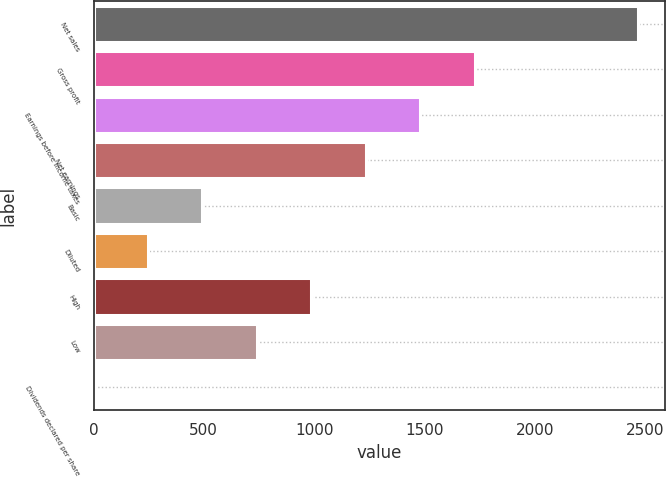Convert chart. <chart><loc_0><loc_0><loc_500><loc_500><bar_chart><fcel>Net sales<fcel>Gross profit<fcel>Earnings before income taxes<fcel>Net earnings<fcel>Basic<fcel>Diluted<fcel>High<fcel>Low<fcel>Dividends declared per share<nl><fcel>2468<fcel>1727.69<fcel>1480.92<fcel>1234.15<fcel>493.84<fcel>247.07<fcel>987.38<fcel>740.61<fcel>0.3<nl></chart> 